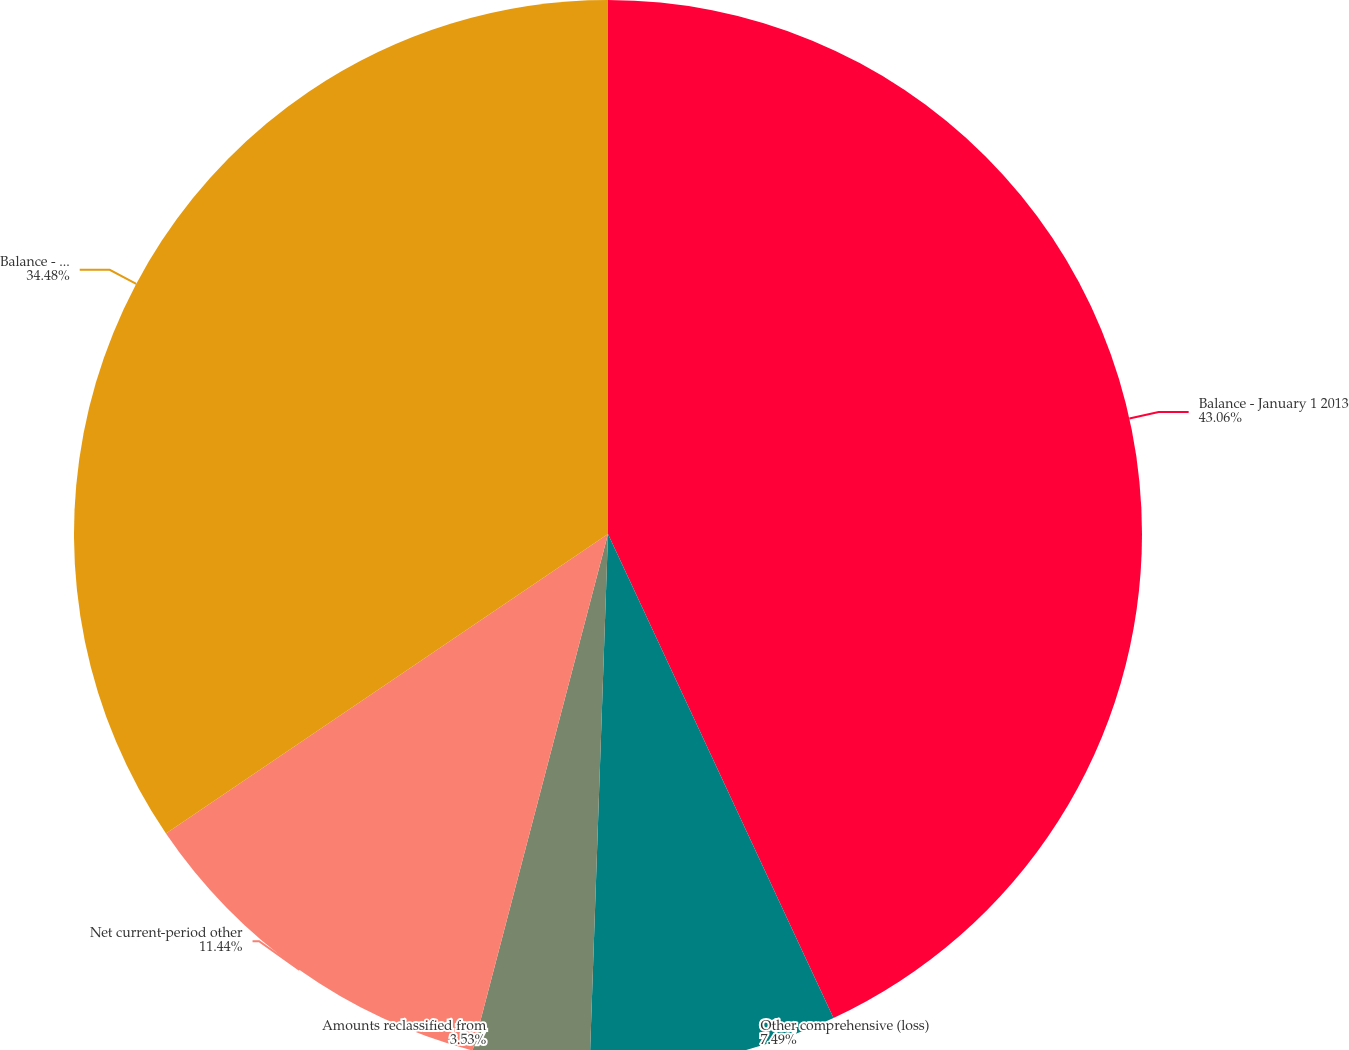Convert chart. <chart><loc_0><loc_0><loc_500><loc_500><pie_chart><fcel>Balance - January 1 2013<fcel>Other comprehensive (loss)<fcel>Amounts reclassified from<fcel>Net current-period other<fcel>Balance - December 31 2013<nl><fcel>43.06%<fcel>7.49%<fcel>3.53%<fcel>11.44%<fcel>34.48%<nl></chart> 